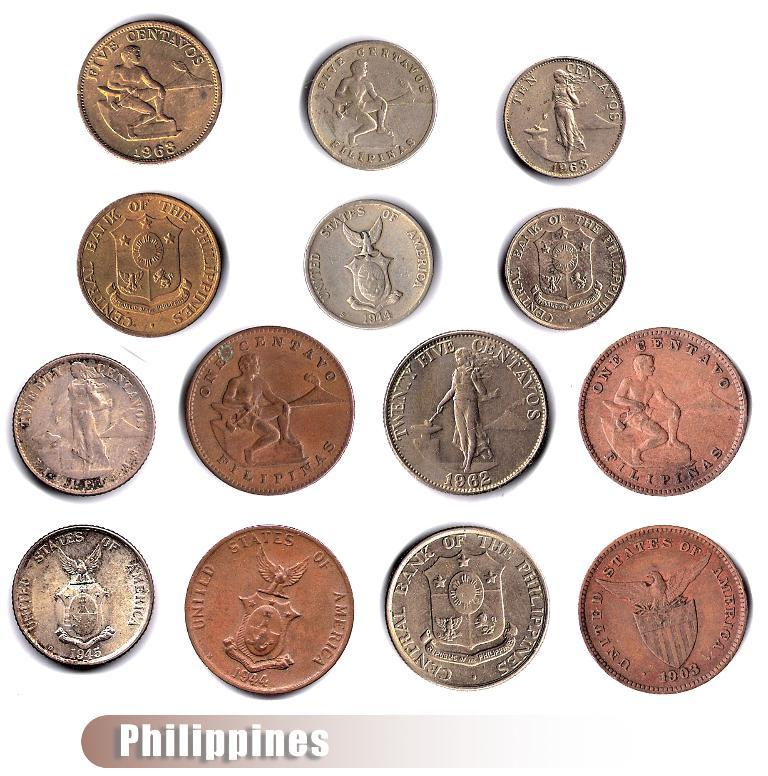What objects are present in the image? There are coins in the image. What features can be seen on the coins? The coins have text and pictures on them. Is there any text outside of the coins in the image? Yes, there is text at the bottom of the image. What shape is the brain in the image? There is no brain present in the image; it only contains coins with text and pictures on them, and text at the bottom. 